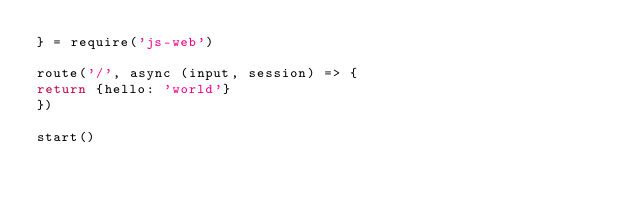<code> <loc_0><loc_0><loc_500><loc_500><_JavaScript_>} = require('js-web')

route('/', async (input, session) => {
return {hello: 'world'}
})

start()</code> 